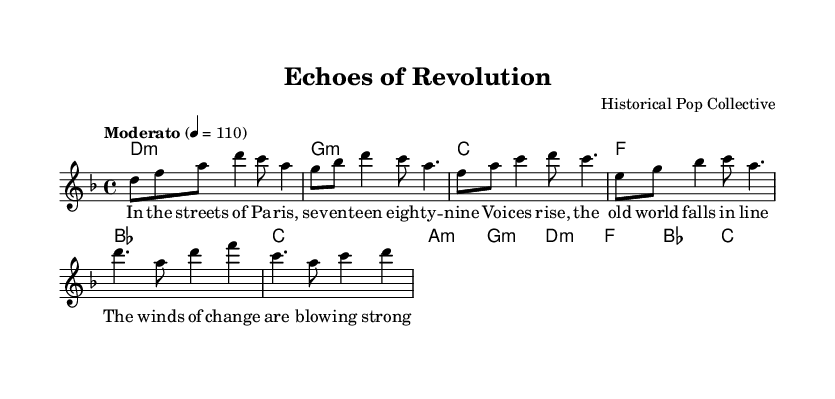What is the key signature of this music? The key signature is indicated at the beginning of the staff, and it shows one flat, which corresponds to D minor.
Answer: D minor What is the time signature of this music? The time signature is shown at the beginning of the score as 4/4, indicating four beats per measure.
Answer: 4/4 What is the tempo marking for this music? The tempo marking appears above the staff as "Moderato," which typically indicates a moderate speed at 110 beats per minute.
Answer: Moderato, 110 How many measures are in the verse section? By counting the groups of notes separated by vertical lines (bar lines) in the verse section, we can see there are four measures.
Answer: Four What is the first chord of the song? The first chord is shown in the chord names section and is written as d1:m, indicating a D minor chord played as a whole note.
Answer: D minor What is the primary theme conveyed in the lyrics? The lyrics of the verse reference themes of revolution and change, specifically mentioning the streets of Paris and a historical event, which indicates the song explores historical events.
Answer: Revolution How many distinct sections are there in the song? The score shows three sections labeled as Verse, Pre-Chorus, and Chorus, totaling three distinct sections in this piece.
Answer: Three 